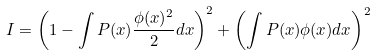Convert formula to latex. <formula><loc_0><loc_0><loc_500><loc_500>I = \left ( 1 - \int P ( x ) \frac { \phi ( x ) ^ { 2 } } { 2 } d x \right ) ^ { 2 } + \left ( \int P ( x ) \phi ( x ) d x \right ) ^ { 2 }</formula> 